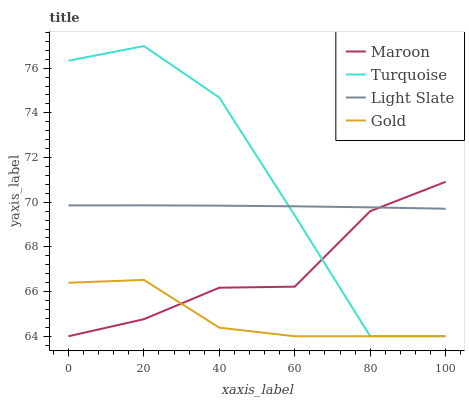Does Gold have the minimum area under the curve?
Answer yes or no. Yes. Does Turquoise have the maximum area under the curve?
Answer yes or no. Yes. Does Turquoise have the minimum area under the curve?
Answer yes or no. No. Does Gold have the maximum area under the curve?
Answer yes or no. No. Is Light Slate the smoothest?
Answer yes or no. Yes. Is Turquoise the roughest?
Answer yes or no. Yes. Is Gold the smoothest?
Answer yes or no. No. Is Gold the roughest?
Answer yes or no. No. Does Turquoise have the highest value?
Answer yes or no. Yes. Does Gold have the highest value?
Answer yes or no. No. Is Gold less than Light Slate?
Answer yes or no. Yes. Is Light Slate greater than Gold?
Answer yes or no. Yes. Does Maroon intersect Turquoise?
Answer yes or no. Yes. Is Maroon less than Turquoise?
Answer yes or no. No. Is Maroon greater than Turquoise?
Answer yes or no. No. Does Gold intersect Light Slate?
Answer yes or no. No. 